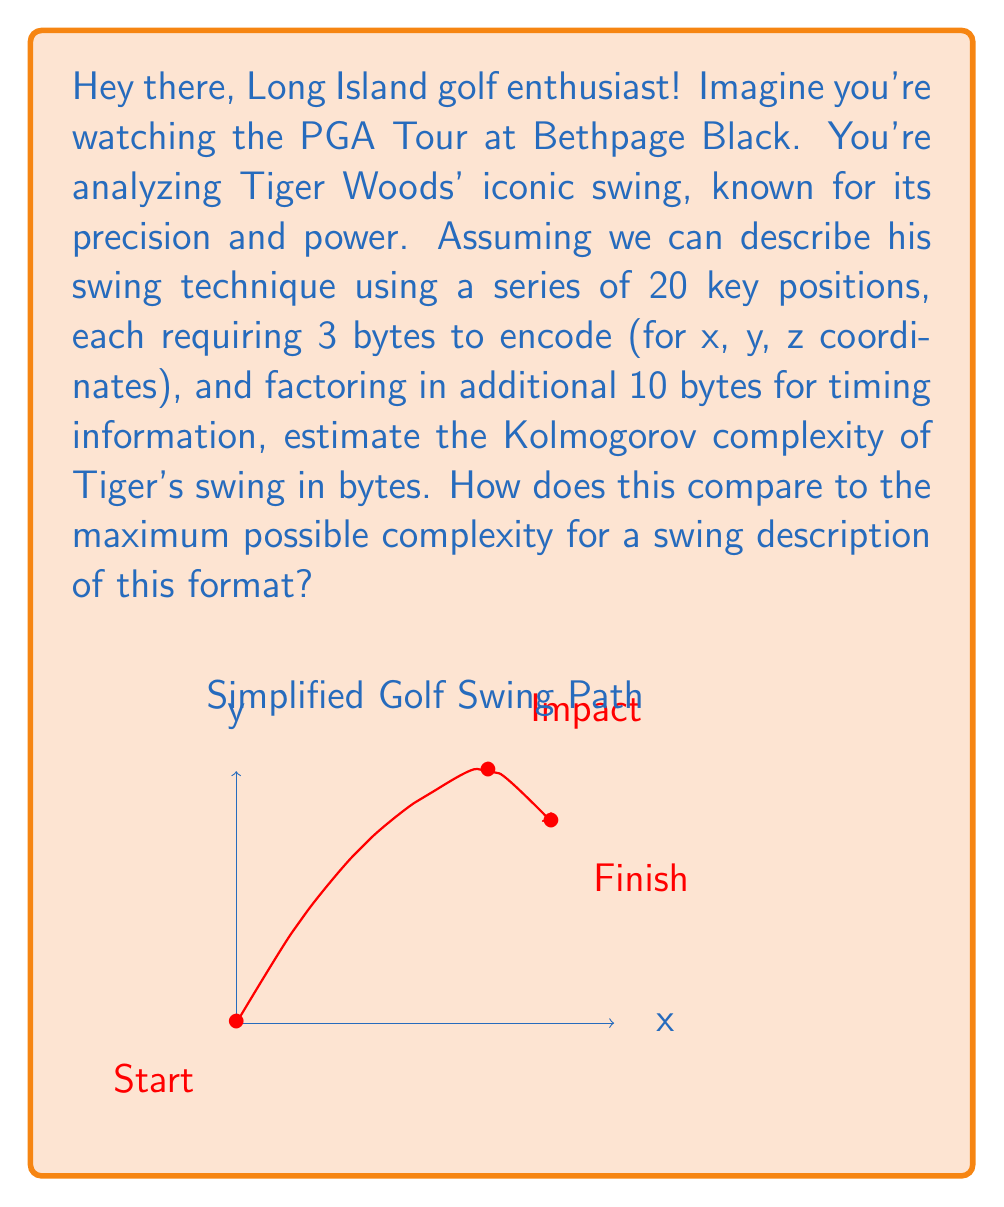Provide a solution to this math problem. Let's break this down step-by-step:

1) First, we need to calculate the total bytes needed to describe the swing:
   - 20 key positions, each requiring 3 bytes
   - 10 bytes for timing information

2) For the key positions:
   $$ 20 \text{ positions} \times 3 \text{ bytes} = 60 \text{ bytes} $$

3) Adding the timing information:
   $$ 60 \text{ bytes} + 10 \text{ bytes} = 70 \text{ bytes} $$

4) This 70 bytes is our estimate of the Kolmogorov complexity of Tiger's swing technique.

5) To compare this to the maximum possible complexity, we need to consider the total number of possible descriptions in this format:
   - Each byte can have $2^8 = 256$ possible values
   - We have 70 bytes in total

6) The maximum complexity would be achieved if each possible description was equally likely, which would require:
   $$ \log_2(256^{70}) = 70 \times 8 = 560 \text{ bits} = 70 \text{ bytes} $$

7) Therefore, our estimate of Tiger's swing complexity matches the maximum possible complexity for this description format, suggesting his swing is highly complex and refined.
Answer: 70 bytes, equal to the maximum possible complexity 